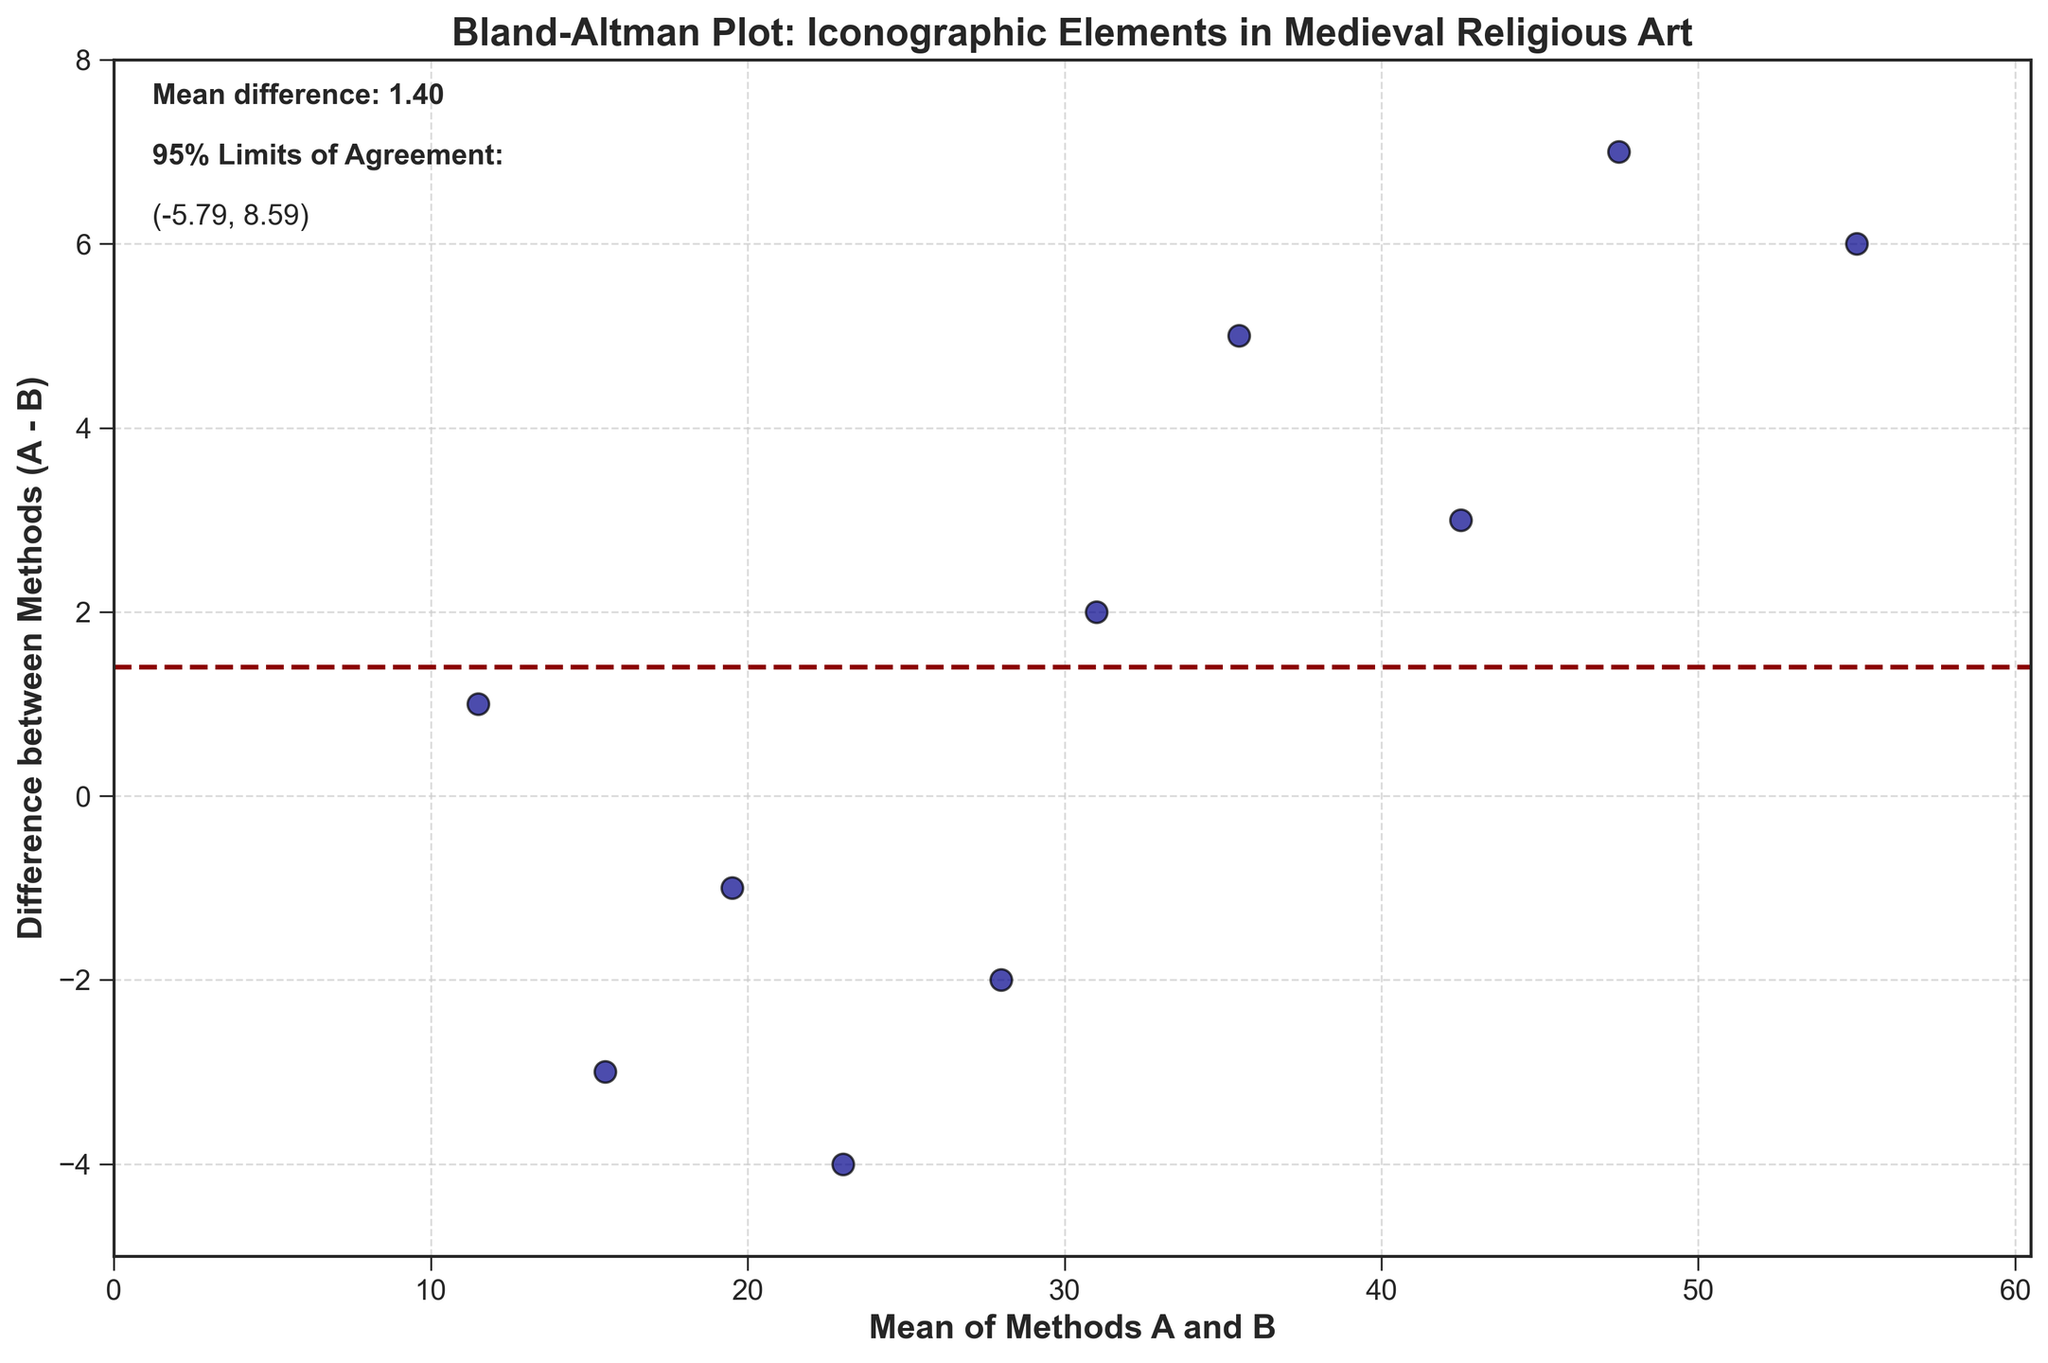What is the title of the Plot? The title of the plot is displayed at the top and reads "Bland-Altman Plot: Iconographic Elements in Medieval Religious Art."
Answer: Bland-Altman Plot: Iconographic Elements in Medieval Religious Art What do the dashed horizontal lines represent? The plot shows a dark red dashed horizontal line that represents the mean difference, and two dark green dashed lines that represent the 95% limits of agreement. These lines are used to analyze the variability and the agreement between the two methods.
Answer: The mean difference and 95% limits of agreement What is the range of the x-axis? The x-axis represents the "Mean of Methods A and B". From the plot, the smallest mean value is around 11.5 and the axis extends just beyond the highest mean value of 55.0, indicating a range from 0 to around 60.5.
Answer: 0 to around 60.5 What is the mean difference between the two methods? The plot provides the mean difference as an annotation at the top left corner. It is displayed as “Mean difference: 1.40.”
Answer: 1.40 Which iconographic element has the maximum difference value? Observing the plot, the data point with the maximum positive difference value is around a mean of 47.5 with a difference of 7. This corresponds to "Last Judgment imagery in Gothic" and "Last Judgment imagery in Byzantine."
Answer: Last Judgment imagery in Gothic and Byzantine What is the overall spread of the differences in the plot? To find the spread of the differences, observe the range from the minimum to the maximum values on the y-axis, which represent the differences. The values range from -4 to 7, giving an overall spread of 11.
Answer: 11 Identify any data points that fall outside the limits of agreement. The limits of agreement are marked by the green dashed lines. Checking visually, the data point with the mean around 47.5 and difference of 7 falls outside the upper limit of agreement.
Answer: The point at mean 47.5, difference 7 Which methods and iconographic elements have the smallest difference? Observing the plot, the data point near mean 19.5 and difference -1 represents "Angel representations in Mozarabic" and "Angel representations in Coptic," which have the smallest negative difference.
Answer: Angel representations in Mozarabic and Coptic What are the lower and upper limits of agreement? These values are annotated on the plot. The lower limit of agreement is at -4.33, and the upper limit of agreement is at 7.13.
Answer: Lower limit: -4.33, Upper limit: 7.13 